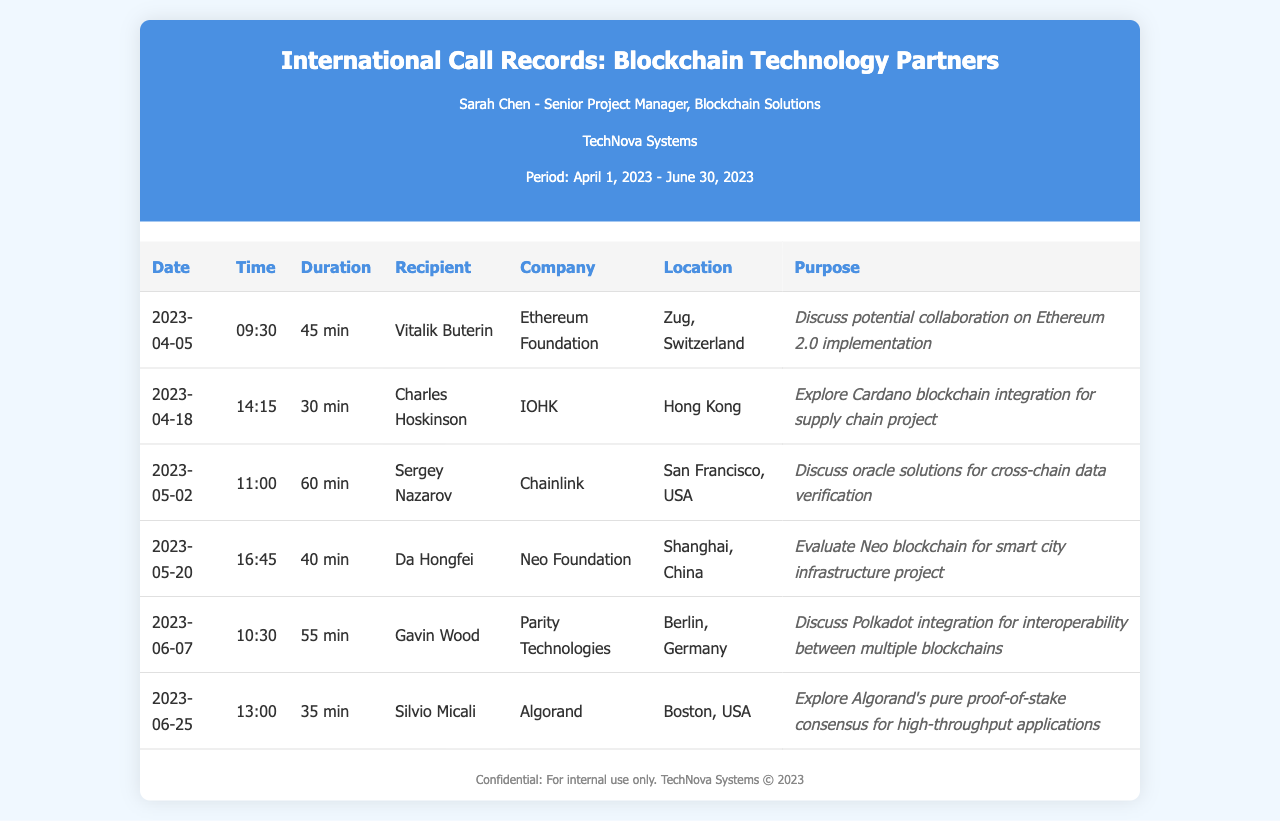What is the date of the first call? The first call listed is on April 5, 2023.
Answer: April 5, 2023 How long did the call with Vitalik Buterin last? The duration for the call with Vitalik Buterin is noted to be 45 minutes.
Answer: 45 min Which company did Charles Hoskinson represent? Charles Hoskinson is associated with IOHK according to the records.
Answer: IOHK What was the purpose of the call on June 25, 2023? The purpose of the call on June 25, 2023, was to explore Algorand's pure proof-of-stake consensus for high-throughput applications.
Answer: Explore Algorand's pure proof-of-stake consensus for high-throughput applications How many calls were made in total during the period? A total of 6 calls are recorded from April to June 2023.
Answer: 6 Which city is associated with the call to Gavin Wood? The call to Gavin Wood was associated with Berlin, Germany.
Answer: Berlin, Germany Who was the recipient of the longest call? The longest call was made to Sergey Nazarov.
Answer: Sergey Nazarov What was the topic discussed in the call with Da Hongfei? The topic discussed was to evaluate Neo blockchain for smart city infrastructure project.
Answer: Evaluate Neo blockchain for smart city infrastructure project 